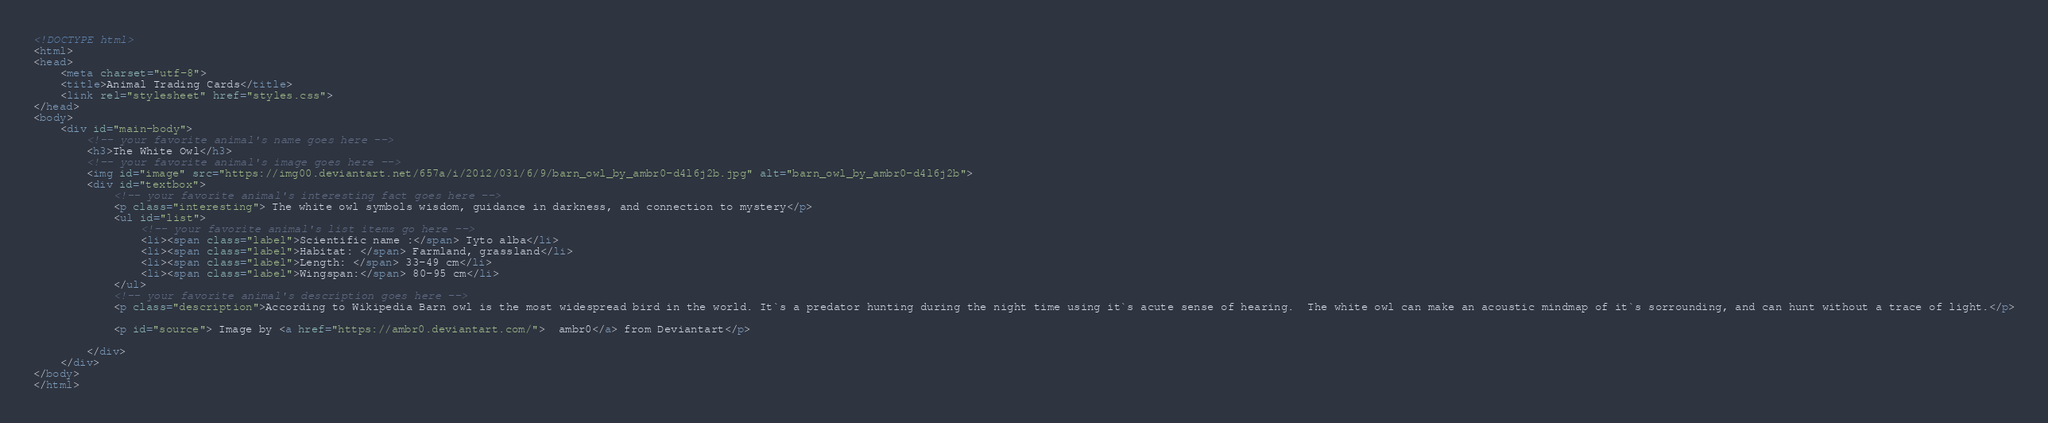Convert code to text. <code><loc_0><loc_0><loc_500><loc_500><_HTML_><!DOCTYPE html>
<html>
<head>
	<meta charset="utf-8">
	<title>Animal Trading Cards</title>
	<link rel="stylesheet" href="styles.css">
</head>
<body>
	<div id="main-body">
		<!-- your favorite animal's name goes here -->
		<h3>The White Owl</h3>
		<!-- your favorite animal's image goes here -->
		<img id="image" src="https://img00.deviantart.net/657a/i/2012/031/6/9/barn_owl_by_ambr0-d4l6j2b.jpg" alt="barn_owl_by_ambr0-d4l6j2b">
		<div id="textbox">
			<!-- your favorite animal's interesting fact goes here -->
			<p class="interesting"> The white owl symbols wisdom, guidance in darkness, and connection to mystery</p>
			<ul id="list">
				<!-- your favorite animal's list items go here -->
				<li><span class="label">Scientific name :</span> Tyto alba</li>
				<li><span class="label">Habitat: </span> Farmland, grassland</li>
				<li><span class="label">Length: </span> 33-49 cm</li>
				<li><span class="label">Wingspan:</span> 80-95 cm</li>
			</ul>
			<!-- your favorite animal's description goes here -->
			<p class="description">According to Wikipedia Barn owl is the most widespread bird in the world. It`s a predator hunting during the night time using it`s acute sense of hearing.  The white owl can make an acoustic mindmap of it`s sorrounding, and can hunt without a trace of light.</p>

			<p id="source"> Image by <a href="https://ambr0.deviantart.com/">  ambr0</a> from Deviantart</p>

		</div>
	</div>
</body>
</html></code> 